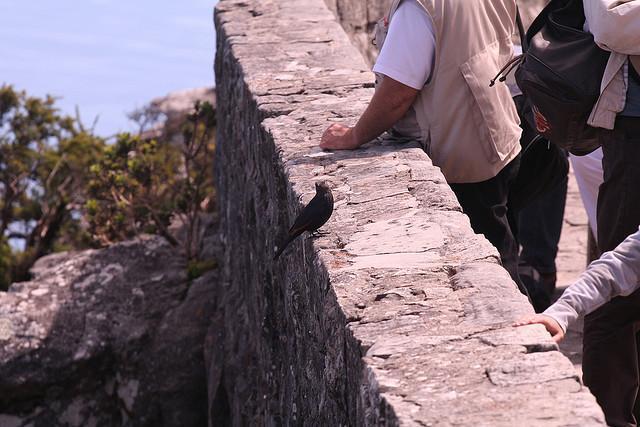How many strings are on the person's backpack?
Give a very brief answer. 2. How many people can you see?
Give a very brief answer. 3. How many suitcases are in the picture on the wall?
Give a very brief answer. 0. 